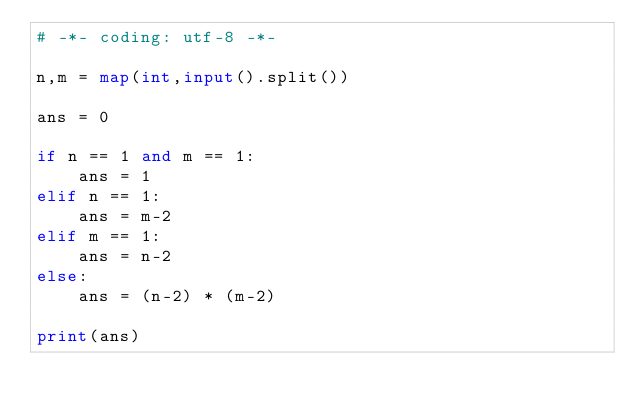<code> <loc_0><loc_0><loc_500><loc_500><_Python_># -*- coding: utf-8 -*-

n,m = map(int,input().split())

ans = 0

if n == 1 and m == 1:
    ans = 1
elif n == 1:
    ans = m-2
elif m == 1:
    ans = n-2
else:
    ans = (n-2) * (m-2)

print(ans)
</code> 